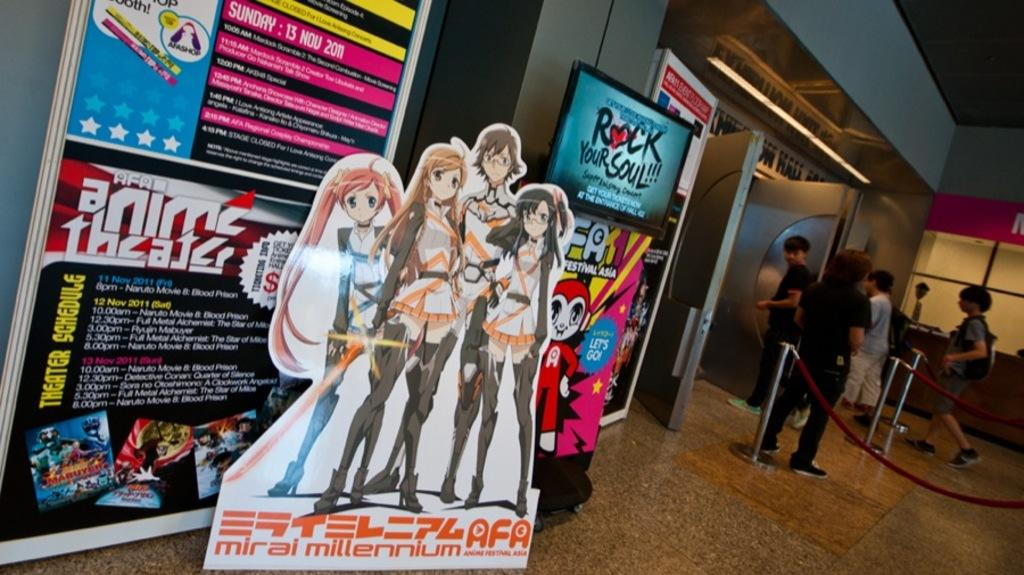<image>
Share a concise interpretation of the image provided. rock your soul is being advertised by the elevator 